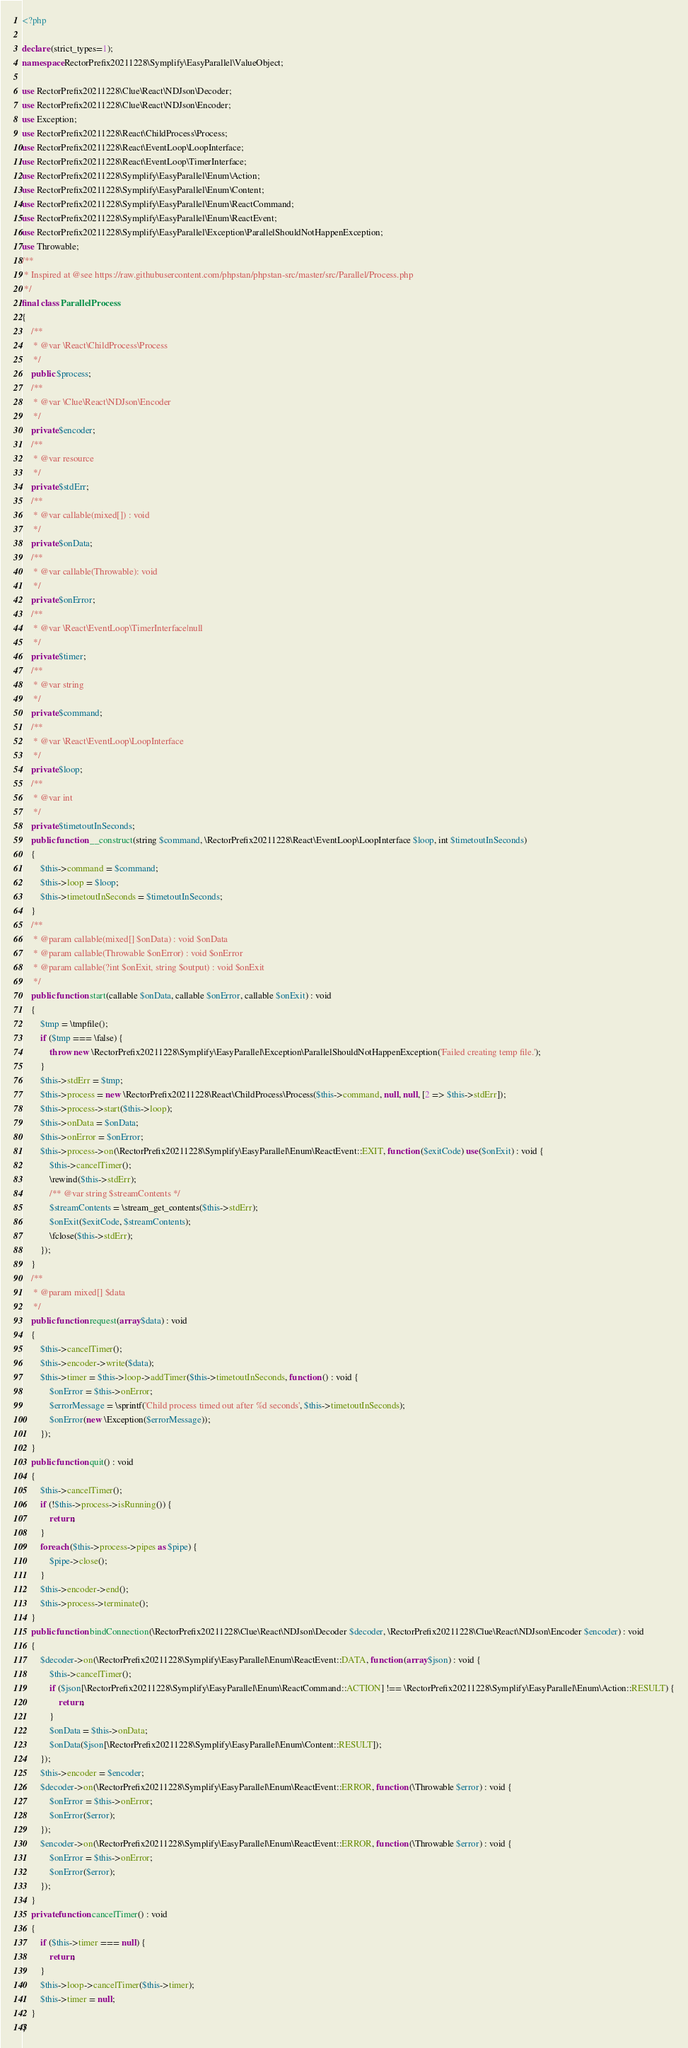<code> <loc_0><loc_0><loc_500><loc_500><_PHP_><?php

declare (strict_types=1);
namespace RectorPrefix20211228\Symplify\EasyParallel\ValueObject;

use RectorPrefix20211228\Clue\React\NDJson\Decoder;
use RectorPrefix20211228\Clue\React\NDJson\Encoder;
use Exception;
use RectorPrefix20211228\React\ChildProcess\Process;
use RectorPrefix20211228\React\EventLoop\LoopInterface;
use RectorPrefix20211228\React\EventLoop\TimerInterface;
use RectorPrefix20211228\Symplify\EasyParallel\Enum\Action;
use RectorPrefix20211228\Symplify\EasyParallel\Enum\Content;
use RectorPrefix20211228\Symplify\EasyParallel\Enum\ReactCommand;
use RectorPrefix20211228\Symplify\EasyParallel\Enum\ReactEvent;
use RectorPrefix20211228\Symplify\EasyParallel\Exception\ParallelShouldNotHappenException;
use Throwable;
/**
 * Inspired at @see https://raw.githubusercontent.com/phpstan/phpstan-src/master/src/Parallel/Process.php
 */
final class ParallelProcess
{
    /**
     * @var \React\ChildProcess\Process
     */
    public $process;
    /**
     * @var \Clue\React\NDJson\Encoder
     */
    private $encoder;
    /**
     * @var resource
     */
    private $stdErr;
    /**
     * @var callable(mixed[]) : void
     */
    private $onData;
    /**
     * @var callable(Throwable): void
     */
    private $onError;
    /**
     * @var \React\EventLoop\TimerInterface|null
     */
    private $timer;
    /**
     * @var string
     */
    private $command;
    /**
     * @var \React\EventLoop\LoopInterface
     */
    private $loop;
    /**
     * @var int
     */
    private $timetoutInSeconds;
    public function __construct(string $command, \RectorPrefix20211228\React\EventLoop\LoopInterface $loop, int $timetoutInSeconds)
    {
        $this->command = $command;
        $this->loop = $loop;
        $this->timetoutInSeconds = $timetoutInSeconds;
    }
    /**
     * @param callable(mixed[] $onData) : void $onData
     * @param callable(Throwable $onError) : void $onError
     * @param callable(?int $onExit, string $output) : void $onExit
     */
    public function start(callable $onData, callable $onError, callable $onExit) : void
    {
        $tmp = \tmpfile();
        if ($tmp === \false) {
            throw new \RectorPrefix20211228\Symplify\EasyParallel\Exception\ParallelShouldNotHappenException('Failed creating temp file.');
        }
        $this->stdErr = $tmp;
        $this->process = new \RectorPrefix20211228\React\ChildProcess\Process($this->command, null, null, [2 => $this->stdErr]);
        $this->process->start($this->loop);
        $this->onData = $onData;
        $this->onError = $onError;
        $this->process->on(\RectorPrefix20211228\Symplify\EasyParallel\Enum\ReactEvent::EXIT, function ($exitCode) use($onExit) : void {
            $this->cancelTimer();
            \rewind($this->stdErr);
            /** @var string $streamContents */
            $streamContents = \stream_get_contents($this->stdErr);
            $onExit($exitCode, $streamContents);
            \fclose($this->stdErr);
        });
    }
    /**
     * @param mixed[] $data
     */
    public function request(array $data) : void
    {
        $this->cancelTimer();
        $this->encoder->write($data);
        $this->timer = $this->loop->addTimer($this->timetoutInSeconds, function () : void {
            $onError = $this->onError;
            $errorMessage = \sprintf('Child process timed out after %d seconds', $this->timetoutInSeconds);
            $onError(new \Exception($errorMessage));
        });
    }
    public function quit() : void
    {
        $this->cancelTimer();
        if (!$this->process->isRunning()) {
            return;
        }
        foreach ($this->process->pipes as $pipe) {
            $pipe->close();
        }
        $this->encoder->end();
        $this->process->terminate();
    }
    public function bindConnection(\RectorPrefix20211228\Clue\React\NDJson\Decoder $decoder, \RectorPrefix20211228\Clue\React\NDJson\Encoder $encoder) : void
    {
        $decoder->on(\RectorPrefix20211228\Symplify\EasyParallel\Enum\ReactEvent::DATA, function (array $json) : void {
            $this->cancelTimer();
            if ($json[\RectorPrefix20211228\Symplify\EasyParallel\Enum\ReactCommand::ACTION] !== \RectorPrefix20211228\Symplify\EasyParallel\Enum\Action::RESULT) {
                return;
            }
            $onData = $this->onData;
            $onData($json[\RectorPrefix20211228\Symplify\EasyParallel\Enum\Content::RESULT]);
        });
        $this->encoder = $encoder;
        $decoder->on(\RectorPrefix20211228\Symplify\EasyParallel\Enum\ReactEvent::ERROR, function (\Throwable $error) : void {
            $onError = $this->onError;
            $onError($error);
        });
        $encoder->on(\RectorPrefix20211228\Symplify\EasyParallel\Enum\ReactEvent::ERROR, function (\Throwable $error) : void {
            $onError = $this->onError;
            $onError($error);
        });
    }
    private function cancelTimer() : void
    {
        if ($this->timer === null) {
            return;
        }
        $this->loop->cancelTimer($this->timer);
        $this->timer = null;
    }
}
</code> 